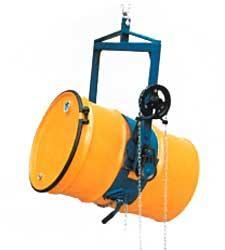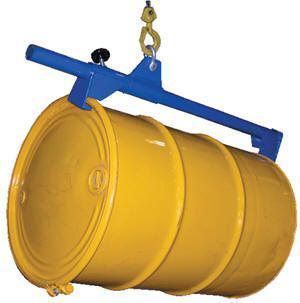The first image is the image on the left, the second image is the image on the right. Examine the images to the left and right. Is the description "One image shows a barrel with a yellow end being hoisted by a blue lift that grips either end and is attached to a hook." accurate? Answer yes or no. Yes. The first image is the image on the left, the second image is the image on the right. Examine the images to the left and right. Is the description "The barrels in the images are hanging horizontally." accurate? Answer yes or no. Yes. 